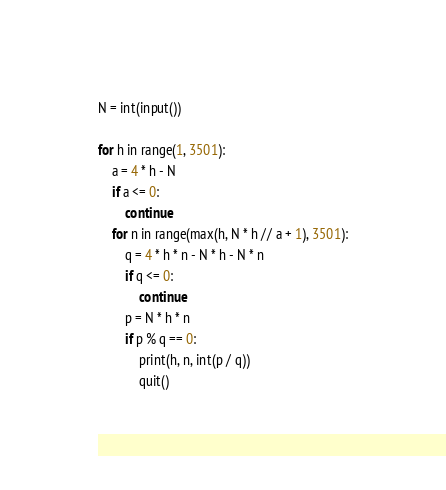<code> <loc_0><loc_0><loc_500><loc_500><_Python_>N = int(input())

for h in range(1, 3501):
    a = 4 * h - N
    if a <= 0:
        continue
    for n in range(max(h, N * h // a + 1), 3501):
        q = 4 * h * n - N * h - N * n
        if q <= 0:
            continue
        p = N * h * n
        if p % q == 0:
            print(h, n, int(p / q))
            quit()
</code> 